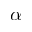Convert formula to latex. <formula><loc_0><loc_0><loc_500><loc_500>\alpha</formula> 